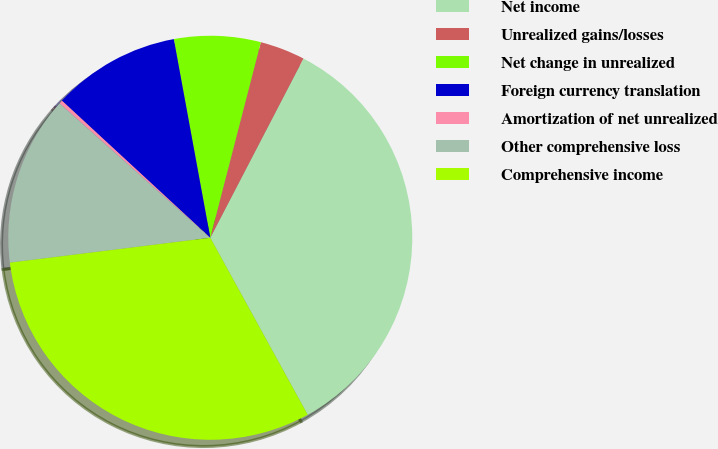<chart> <loc_0><loc_0><loc_500><loc_500><pie_chart><fcel>Net income<fcel>Unrealized gains/losses<fcel>Net change in unrealized<fcel>Foreign currency translation<fcel>Amortization of net unrealized<fcel>Other comprehensive loss<fcel>Comprehensive income<nl><fcel>34.37%<fcel>3.6%<fcel>6.92%<fcel>10.24%<fcel>0.28%<fcel>13.56%<fcel>31.05%<nl></chart> 